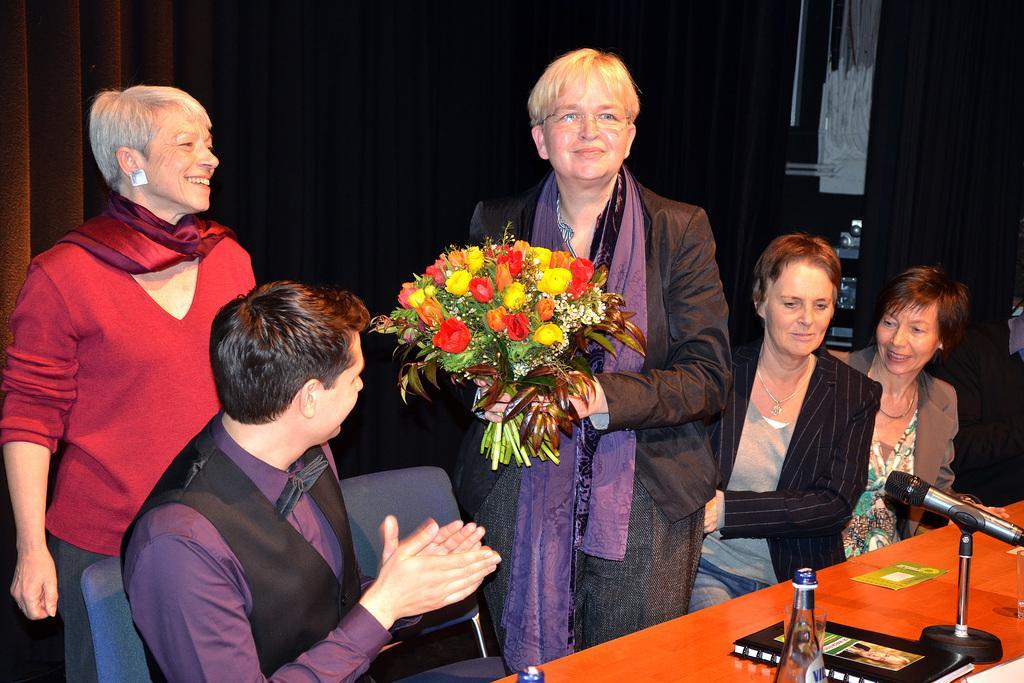How would you summarize this image in a sentence or two? In this picture there is a woman who is holding a flower bouquet, beside her there is a woman who is wearing blazer, t-shirt and jeans. She is sitting near to the table. On the table I can see the water bottle, book, mice and other objects. On the right there is a woman who is sitting near to the wall. On the left there is another woman who is standing near to the chairs. In the bottom left there is a man who is sitting on the chair. 